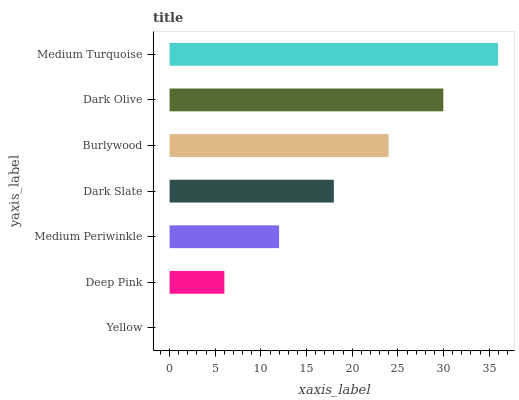Is Yellow the minimum?
Answer yes or no. Yes. Is Medium Turquoise the maximum?
Answer yes or no. Yes. Is Deep Pink the minimum?
Answer yes or no. No. Is Deep Pink the maximum?
Answer yes or no. No. Is Deep Pink greater than Yellow?
Answer yes or no. Yes. Is Yellow less than Deep Pink?
Answer yes or no. Yes. Is Yellow greater than Deep Pink?
Answer yes or no. No. Is Deep Pink less than Yellow?
Answer yes or no. No. Is Dark Slate the high median?
Answer yes or no. Yes. Is Dark Slate the low median?
Answer yes or no. Yes. Is Dark Olive the high median?
Answer yes or no. No. Is Medium Turquoise the low median?
Answer yes or no. No. 